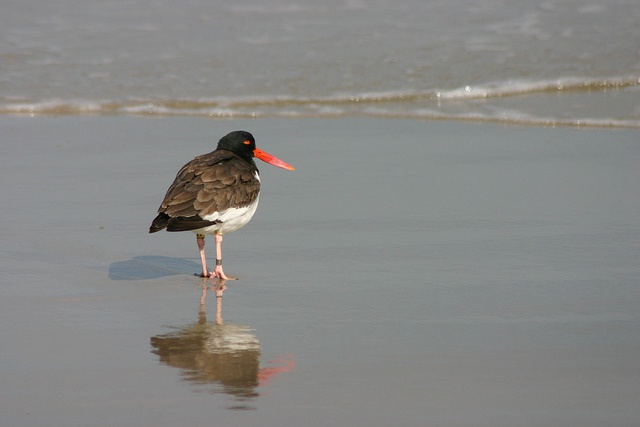Describe the objects in this image and their specific colors. I can see a bird in gray, black, and maroon tones in this image. 